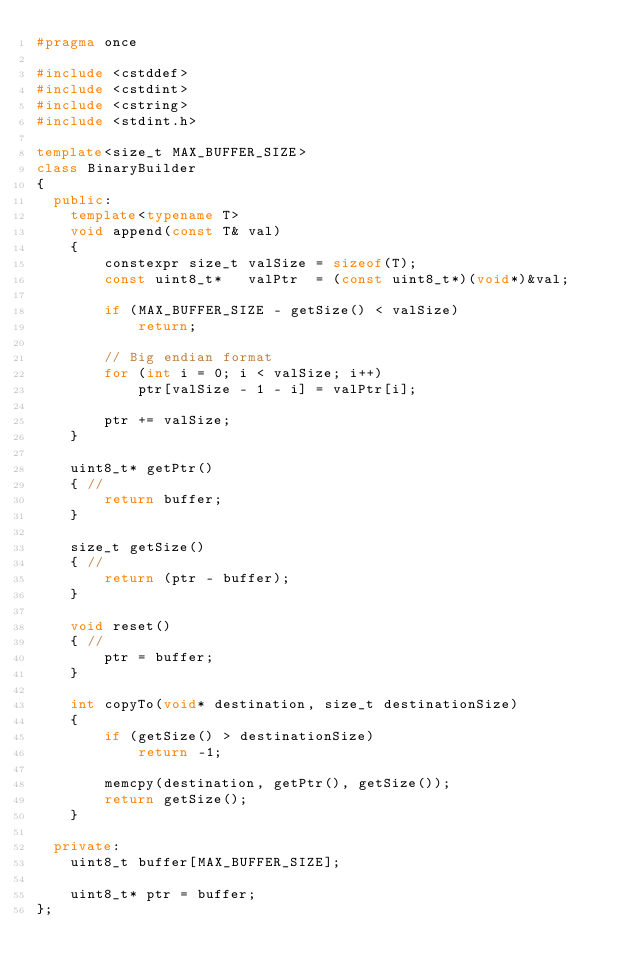Convert code to text. <code><loc_0><loc_0><loc_500><loc_500><_C++_>#pragma once

#include <cstddef>
#include <cstdint>
#include <cstring>
#include <stdint.h>

template<size_t MAX_BUFFER_SIZE>
class BinaryBuilder
{
  public:
    template<typename T>
    void append(const T& val)
    {
        constexpr size_t valSize = sizeof(T);
        const uint8_t*   valPtr  = (const uint8_t*)(void*)&val;

        if (MAX_BUFFER_SIZE - getSize() < valSize)
            return;

        // Big endian format
        for (int i = 0; i < valSize; i++)
            ptr[valSize - 1 - i] = valPtr[i];

        ptr += valSize;
    }

    uint8_t* getPtr()
    { //
        return buffer;
    }

    size_t getSize()
    { //
        return (ptr - buffer);
    }

    void reset()
    { //
        ptr = buffer;
    }

    int copyTo(void* destination, size_t destinationSize)
    {
        if (getSize() > destinationSize)
            return -1;

        memcpy(destination, getPtr(), getSize());
        return getSize();
    }

  private:
    uint8_t buffer[MAX_BUFFER_SIZE];

    uint8_t* ptr = buffer;
};
</code> 